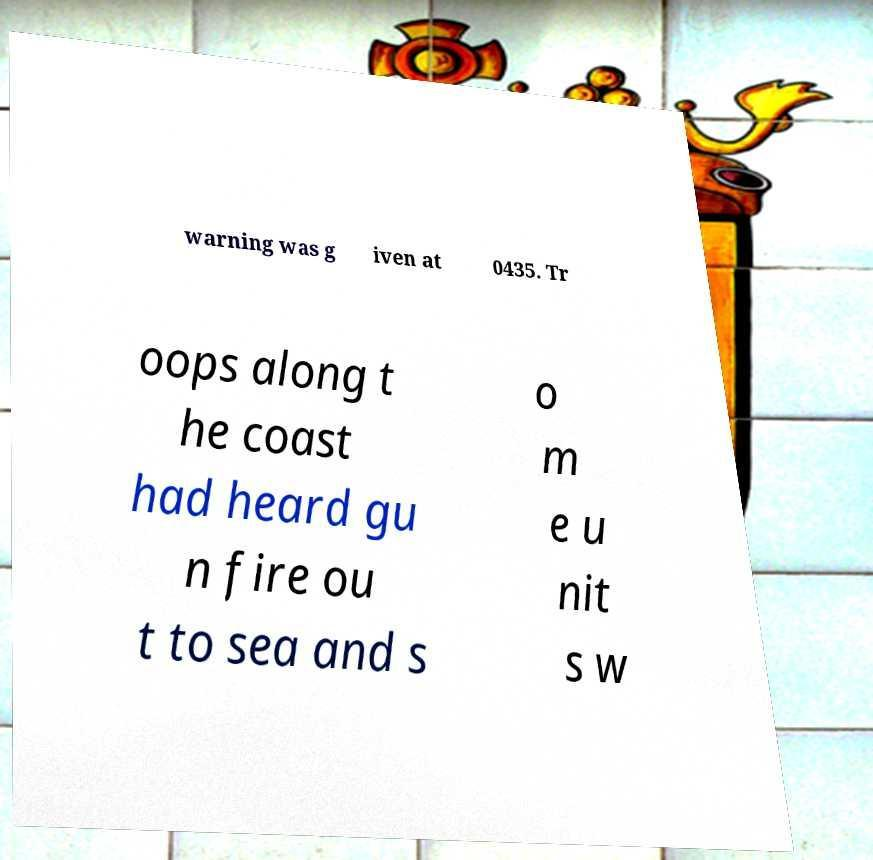Can you accurately transcribe the text from the provided image for me? warning was g iven at 0435. Tr oops along t he coast had heard gu n fire ou t to sea and s o m e u nit s w 